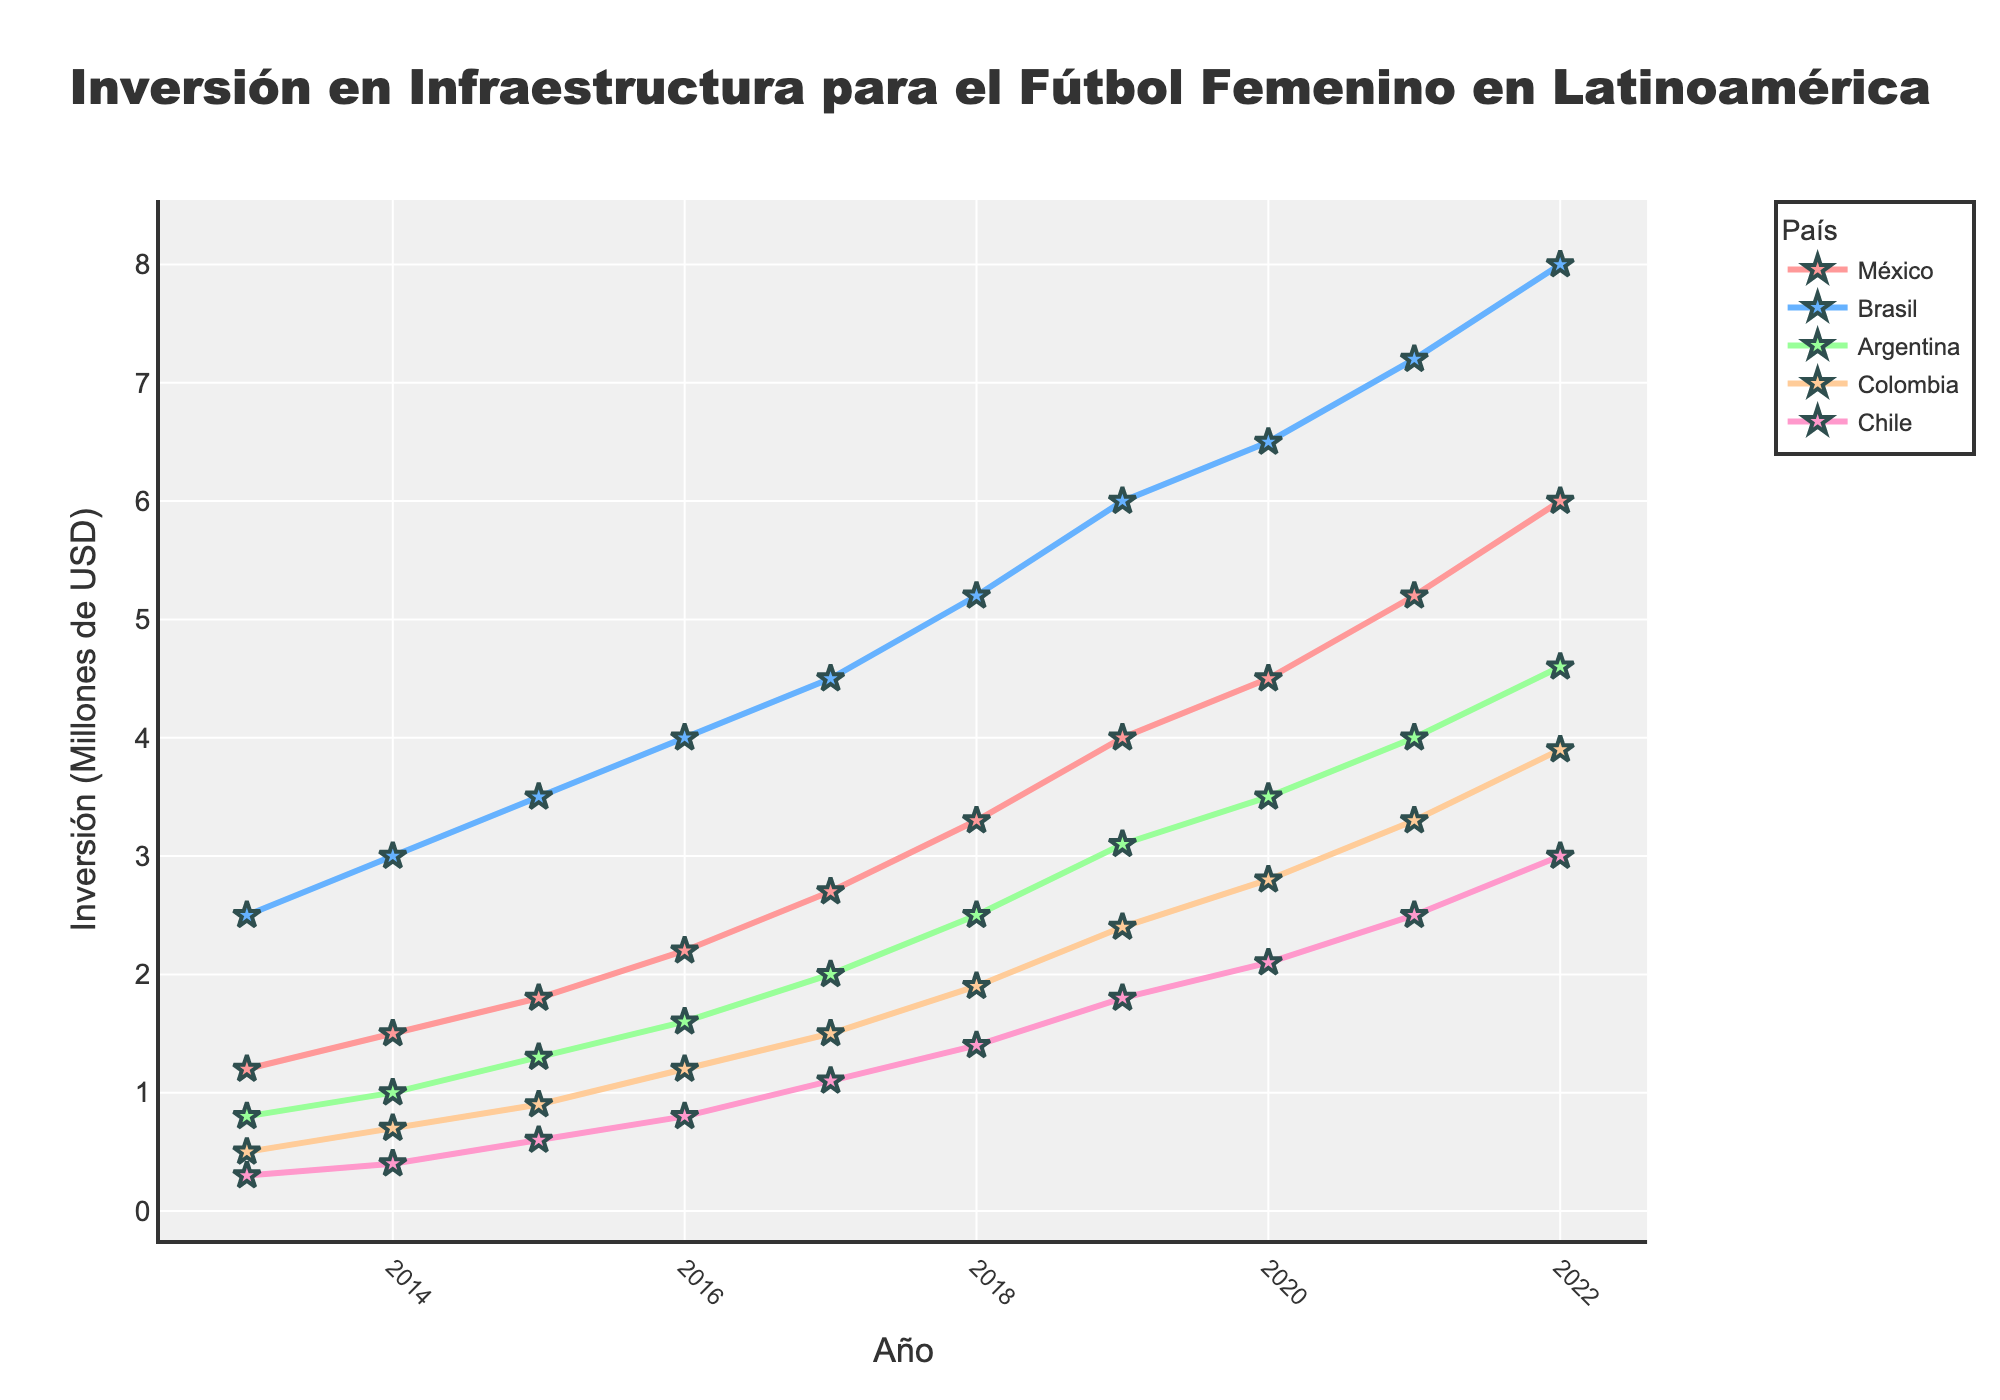¿Cuál es el país con la mayor inversión en infraestructura para el fútbol femenino en 2022? Observando la gráfica, la línea más alta en 2022 corresponde a Brasil.
Answer: Brasil ¿Cuál fue la inversión total combinada de México y Argentina en 2020? En la gráfica, se puede ver que México invirtió 4.5 millones de USD y Argentina invirtió 3.5 millones de USD en 2020. Sumando estas cifras: 4.5 + 3.5 = 8.0 millones de USD.
Answer: 8.0 millones de USD ¿Cómo ha cambiado la inversión de Chile entre 2013 y 2022? La inversión de Chile en 2013 fue de 0.3 millones de USD y en 2022 fue de 3.0 millones de USD. Para encontrar el cambio: 3.0 - 0.3 = 2.7 millones de USD.
Answer: Aumentó en 2.7 millones de USD Comparando la inversión de México y Colombia en 2018, ¿cuál fue mayor y por cuánto? La inversión de México en 2018 fue de 3.3 millones de USD y la de Colombia fue de 1.9 millones de USD. La diferencia es: 3.3 - 1.9 = 1.4 millones de USD.
Answer: México por 1.4 millones de USD ¿Cuál fue la tasa de crecimiento promedio anual de la inversión en Brasil de 2016 a 2020? En 2016, la inversión en Brasil fue de 4.0 millones de USD y en 2020 fue de 6.5 millones de USD. Primero, encontramos el incremento total: 6.5 - 4.0 = 2.5 millones de USD. Luego, dividimos este incremento por el número de años: 2.5 / 4 = 0.625 millones de USD por año.
Answer: 0.625 millones de USD por año ¿Cuántos países superaron una inversión de 1 millón de USD en 2017? En la gráfica para el año 2017, observamos las inversiones de los países: México (2.7), Brasil (4.5), Argentina (2.0), y Colombia (1.5). Todos ellos superaron 1 millón de USD.
Answer: 4 países ¿Cuál fue el incremento relativo de la inversión en Argentina entre 2014 y 2015? La inversión en Argentina en 2014 fue de 1.0 millones de USD y en 2015 fue de 1.3 millones de USD. La diferencia es 1.3 - 1.0 = 0.3 millones de USD. Para calcular el incremento relativo: (0.3 / 1.0) * 100 = 30%.
Answer: 30% ¿Cuál país tuvo el menor incremento absoluto en inversión entre 2019 y 2020, y cuál fue este incremento? Observando las diferencias entre los años 2019 y 2020: México (4.5 - 4.0 = 0.5), Brasil (6.5 - 6.0 = 0.5), Argentina (3.5 - 3.1 = 0.4), Colombia (2.8 - 2.4 = 0.4), y Chile (2.1 - 1.8 = 0.3). El menor incremento fue el de Chile.
Answer: Chile, 0.3 millones de USD ¿Qué país mostró la tendencia de crecimiento más constante durante la década? Observando las líneas en la gráfica, la línea de México muestra un aumento constante en inversión desde 2013 hasta 2022 sin fluctuaciones notables.
Answer: México En el año 2016, ¿cuántos países tenían una inversión inferior a 2 millones de USD? Observando las inversiones en 2016: México (2.2), Brasil (4.0), Argentina (1.6), Colombia (1.2), y Chile (0.8). Solo Chile tiene una inversión inferior a 2 millones de USD en este año.
Answer: 1 país 